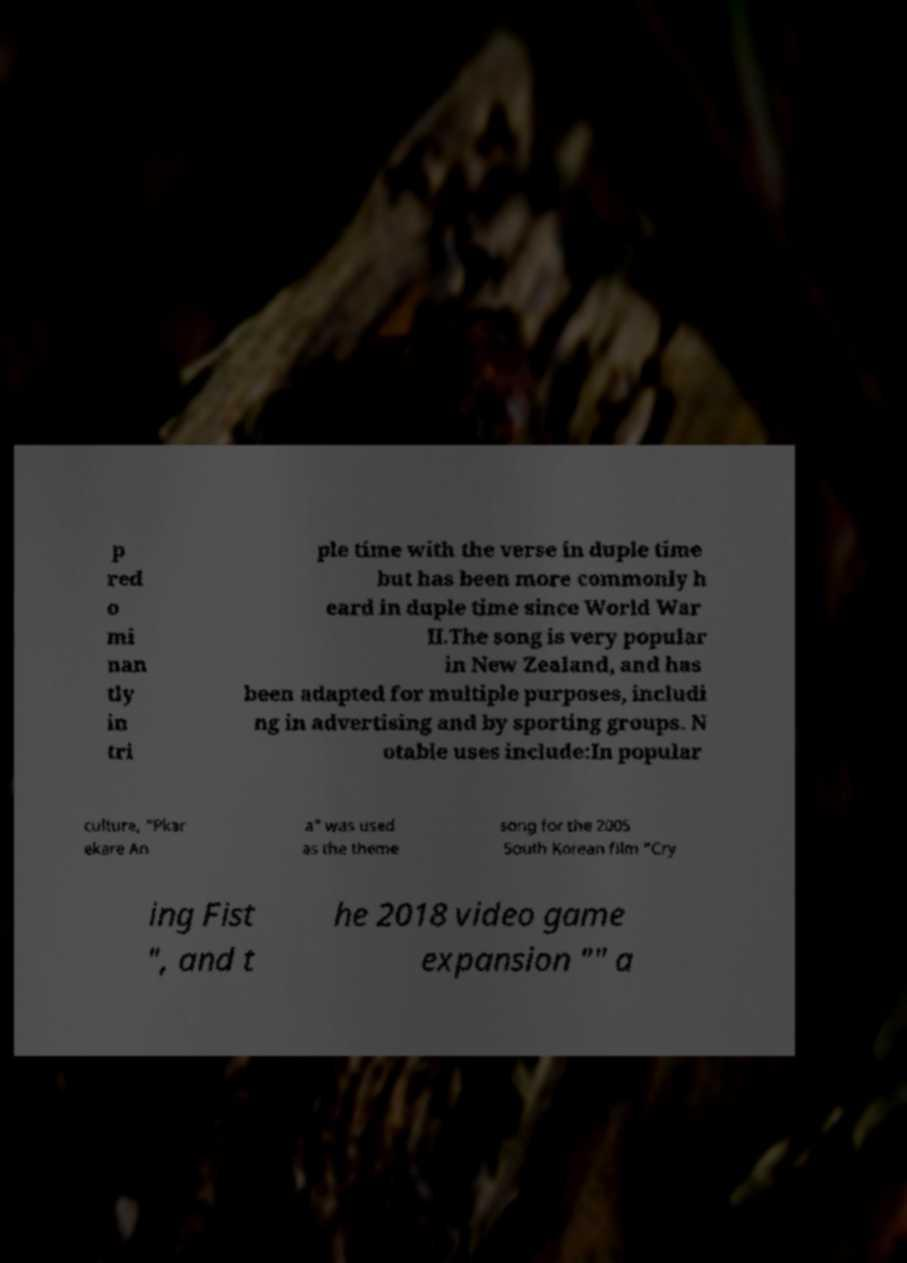Can you read and provide the text displayed in the image?This photo seems to have some interesting text. Can you extract and type it out for me? p red o mi nan tly in tri ple time with the verse in duple time but has been more commonly h eard in duple time since World War II.The song is very popular in New Zealand, and has been adapted for multiple purposes, includi ng in advertising and by sporting groups. N otable uses include:In popular culture, "Pkar ekare An a" was used as the theme song for the 2005 South Korean film "Cry ing Fist ", and t he 2018 video game expansion "" a 